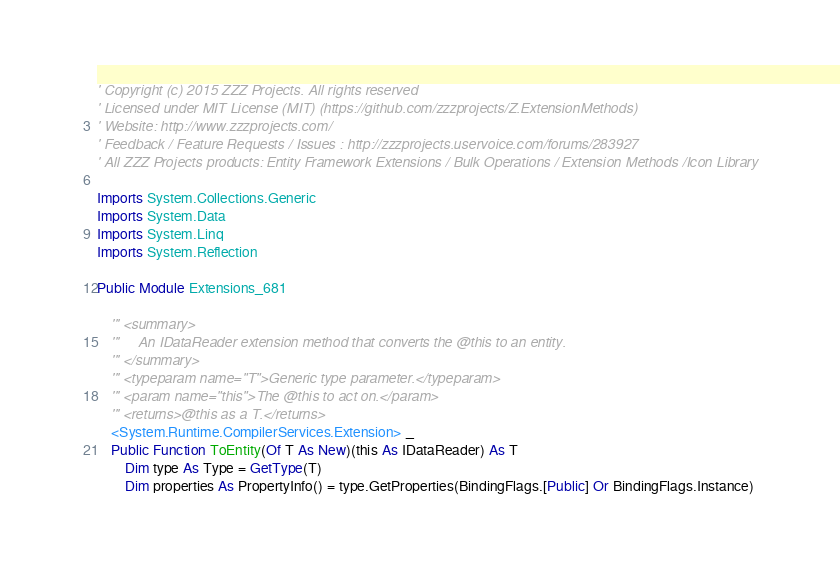Convert code to text. <code><loc_0><loc_0><loc_500><loc_500><_VisualBasic_>
' Copyright (c) 2015 ZZZ Projects. All rights reserved
' Licensed under MIT License (MIT) (https://github.com/zzzprojects/Z.ExtensionMethods)
' Website: http://www.zzzprojects.com/
' Feedback / Feature Requests / Issues : http://zzzprojects.uservoice.com/forums/283927
' All ZZZ Projects products: Entity Framework Extensions / Bulk Operations / Extension Methods /Icon Library

Imports System.Collections.Generic
Imports System.Data
Imports System.Linq
Imports System.Reflection

Public Module Extensions_681

	''' <summary>
	'''     An IDataReader extension method that converts the @this to an entity.
	''' </summary>
	''' <typeparam name="T">Generic type parameter.</typeparam>
	''' <param name="this">The @this to act on.</param>
	''' <returns>@this as a T.</returns>
	<System.Runtime.CompilerServices.Extension> _
	Public Function ToEntity(Of T As New)(this As IDataReader) As T
		Dim type As Type = GetType(T)
		Dim properties As PropertyInfo() = type.GetProperties(BindingFlags.[Public] Or BindingFlags.Instance)</code> 